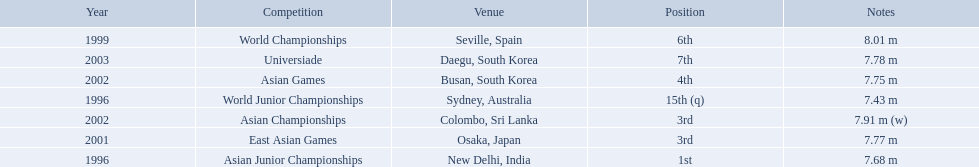What jumps did huang le make in 2002? 7.91 m (w), 7.75 m. Which jump was the longest? 7.91 m (w). 